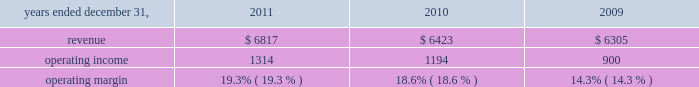2022 net derivative losses of $ 13 million .
Review by segment general we serve clients through the following segments : 2022 risk solutions acts as an advisor and insurance and reinsurance broker , helping clients manage their risks , via consultation , as well as negotiation and placement of insurance risk with insurance carriers through our global distribution network .
2022 hr solutions partners with organizations to solve their most complex benefits , talent and related financial challenges , and improve business performance by designing , implementing , communicating and administering a wide range of human capital , retirement , investment management , health care , compensation and talent management strategies .
Risk solutions .
The demand for property and casualty insurance generally rises as the overall level of economic activity increases and generally falls as such activity decreases , affecting both the commissions and fees generated by our brokerage business .
The economic activity that impacts property and casualty insurance is described as exposure units , and is closely correlated with employment levels , corporate revenue and asset values .
During 2011 we began to see some improvement in pricing ; however , we would still consider this to be a 2018 2018soft market , 2019 2019 which began in 2007 .
In a soft market , premium rates flatten or decrease , along with commission revenues , due to increased competition for market share among insurance carriers or increased underwriting capacity .
Changes in premiums have a direct and potentially material impact on the insurance brokerage industry , as commission revenues are generally based on a percentage of the premiums paid by insureds .
In 2011 , pricing showed signs of stabilization and improvement in both our retail and reinsurance brokerage product lines and we expect this trend to slowly continue into 2012 .
Additionally , beginning in late 2008 and continuing through 2011 , we faced difficult conditions as a result of unprecedented disruptions in the global economy , the repricing of credit risk and the deterioration of the financial markets .
Weak global economic conditions have reduced our customers 2019 demand for our brokerage products , which have had a negative impact on our operational results .
Risk solutions generated approximately 60% ( 60 % ) of our consolidated total revenues in 2011 .
Revenues are generated primarily through fees paid by clients , commissions and fees paid by insurance and reinsurance companies , and investment income on funds held on behalf of clients .
Our revenues vary from quarter to quarter throughout the year as a result of the timing of our clients 2019 policy renewals , the net effect of new and lost business , the timing of services provided to our clients , and the income we earn on investments , which is heavily influenced by short-term interest rates .
We operate in a highly competitive industry and compete with many retail insurance brokerage and agency firms , as well as with individual brokers , agents , and direct writers of insurance coverage .
Specifically , we address the highly specialized product development and risk management needs of commercial enterprises , professional groups , insurance companies , governments , health care providers , and non-profit groups , among others ; provide affinity products for professional liability , life , disability .
What was the percent of the increase in the operating income from 2010 to 2011? 
Rationale: the percent of the increase in the operating income increased by 10.1% from 2010 to 2011
Computations: ((1314 - 1194) / 1194)
Answer: 0.1005. 